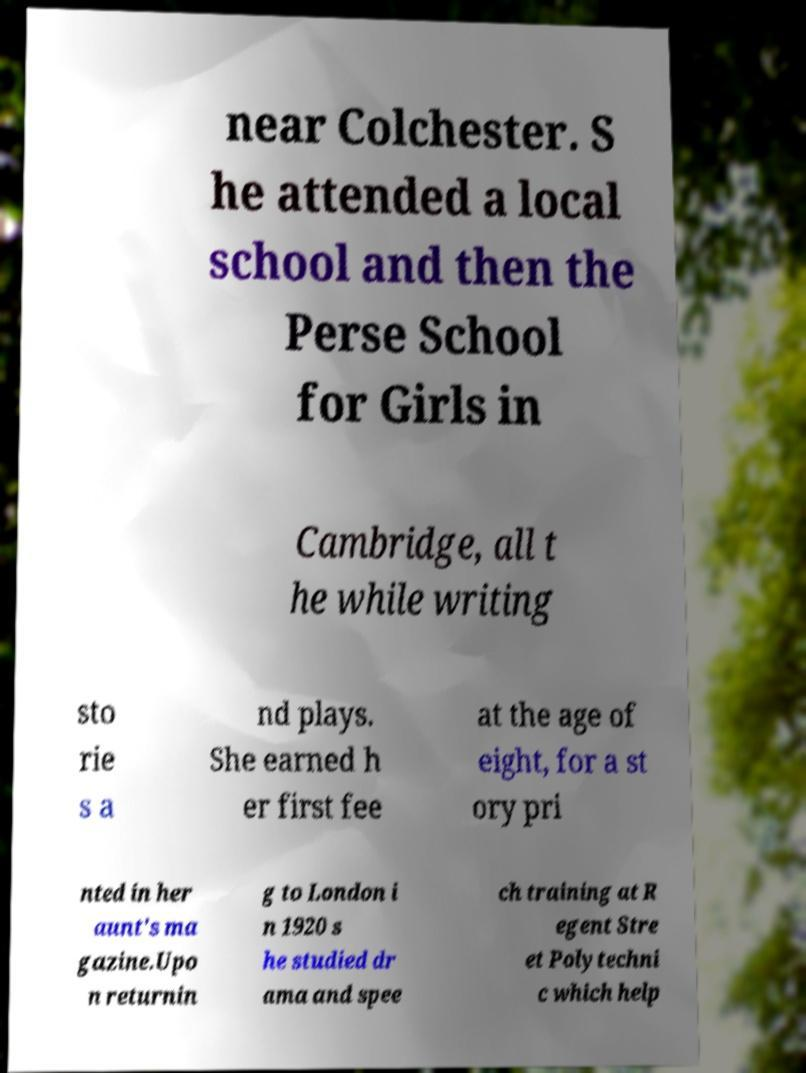Could you extract and type out the text from this image? near Colchester. S he attended a local school and then the Perse School for Girls in Cambridge, all t he while writing sto rie s a nd plays. She earned h er first fee at the age of eight, for a st ory pri nted in her aunt's ma gazine.Upo n returnin g to London i n 1920 s he studied dr ama and spee ch training at R egent Stre et Polytechni c which help 